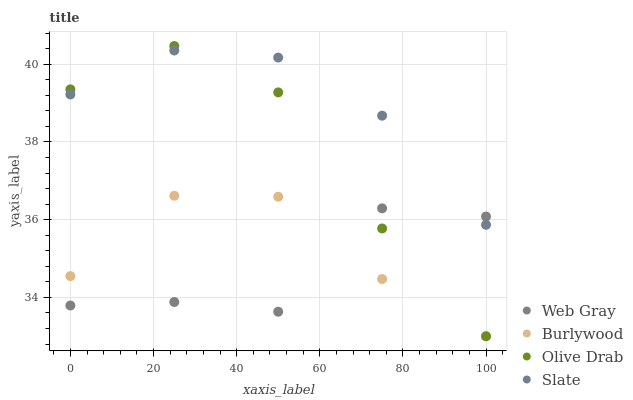Does Web Gray have the minimum area under the curve?
Answer yes or no. Yes. Does Slate have the maximum area under the curve?
Answer yes or no. Yes. Does Slate have the minimum area under the curve?
Answer yes or no. No. Does Web Gray have the maximum area under the curve?
Answer yes or no. No. Is Slate the smoothest?
Answer yes or no. Yes. Is Web Gray the roughest?
Answer yes or no. Yes. Is Web Gray the smoothest?
Answer yes or no. No. Is Slate the roughest?
Answer yes or no. No. Does Burlywood have the lowest value?
Answer yes or no. Yes. Does Web Gray have the lowest value?
Answer yes or no. No. Does Olive Drab have the highest value?
Answer yes or no. Yes. Does Slate have the highest value?
Answer yes or no. No. Is Burlywood less than Slate?
Answer yes or no. Yes. Is Slate greater than Burlywood?
Answer yes or no. Yes. Does Web Gray intersect Olive Drab?
Answer yes or no. Yes. Is Web Gray less than Olive Drab?
Answer yes or no. No. Is Web Gray greater than Olive Drab?
Answer yes or no. No. Does Burlywood intersect Slate?
Answer yes or no. No. 